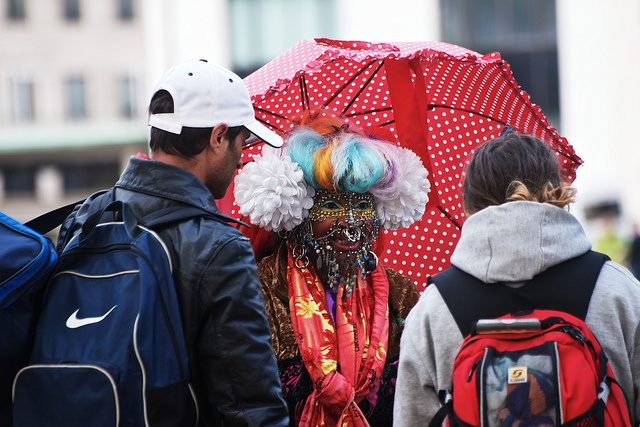Describe the objects in this image and their specific colors. I can see people in lightgray, black, darkgray, and gray tones, people in lightgray, black, maroon, and brown tones, backpack in lightgray, black, navy, darkblue, and gray tones, people in lightgray, black, and darkblue tones, and umbrella in lightgray, brown, and lavender tones in this image. 